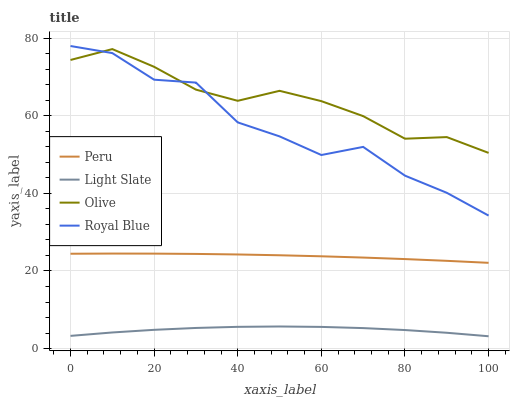Does Light Slate have the minimum area under the curve?
Answer yes or no. Yes. Does Olive have the maximum area under the curve?
Answer yes or no. Yes. Does Peru have the minimum area under the curve?
Answer yes or no. No. Does Peru have the maximum area under the curve?
Answer yes or no. No. Is Peru the smoothest?
Answer yes or no. Yes. Is Royal Blue the roughest?
Answer yes or no. Yes. Is Olive the smoothest?
Answer yes or no. No. Is Olive the roughest?
Answer yes or no. No. Does Light Slate have the lowest value?
Answer yes or no. Yes. Does Peru have the lowest value?
Answer yes or no. No. Does Royal Blue have the highest value?
Answer yes or no. Yes. Does Olive have the highest value?
Answer yes or no. No. Is Light Slate less than Peru?
Answer yes or no. Yes. Is Peru greater than Light Slate?
Answer yes or no. Yes. Does Royal Blue intersect Olive?
Answer yes or no. Yes. Is Royal Blue less than Olive?
Answer yes or no. No. Is Royal Blue greater than Olive?
Answer yes or no. No. Does Light Slate intersect Peru?
Answer yes or no. No. 